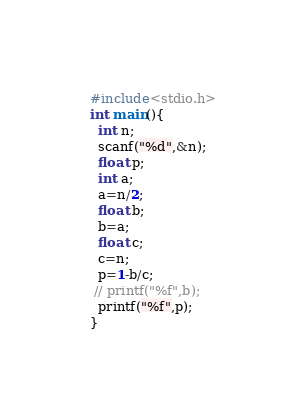Convert code to text. <code><loc_0><loc_0><loc_500><loc_500><_C_>#include<stdio.h>
int main(){
  int n;
  scanf("%d",&n);
  float p;
  int a;
  a=n/2;
  float b;
  b=a;
  float c;
  c=n;
  p=1-b/c;
 // printf("%f",b);
  printf("%f",p);
}
</code> 